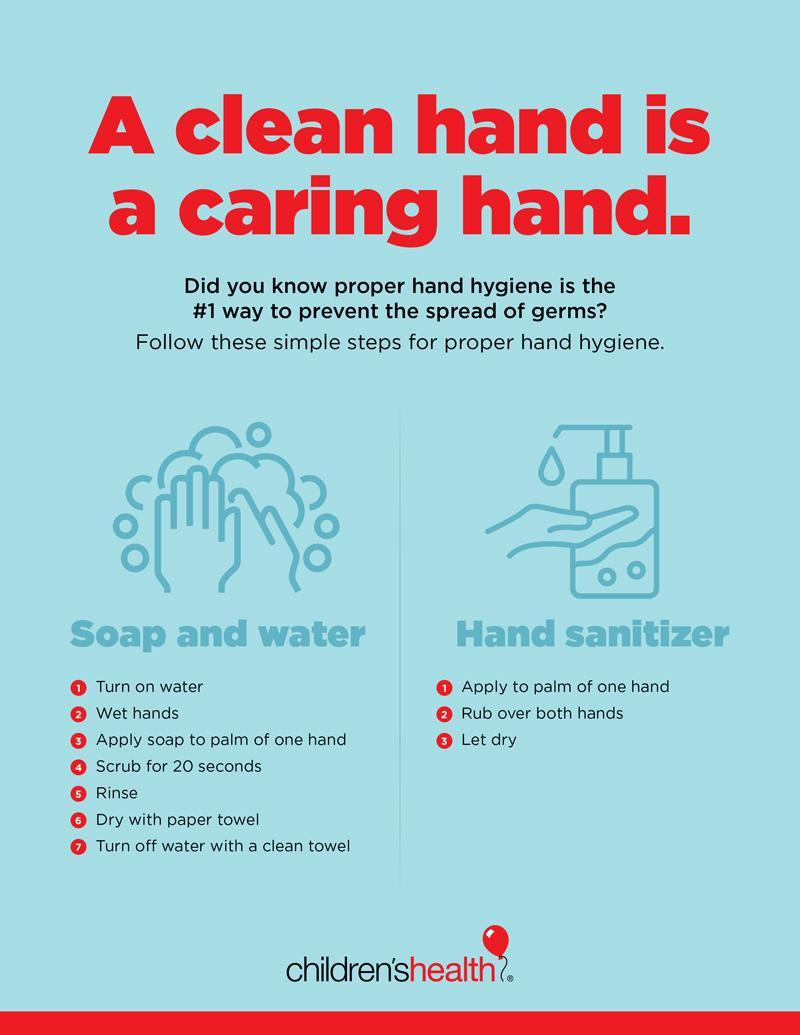What are two methods that can be followed to ensure good hand hygiene?
Answer the question with a short phrase. Soap and water, Hand sanitizer 